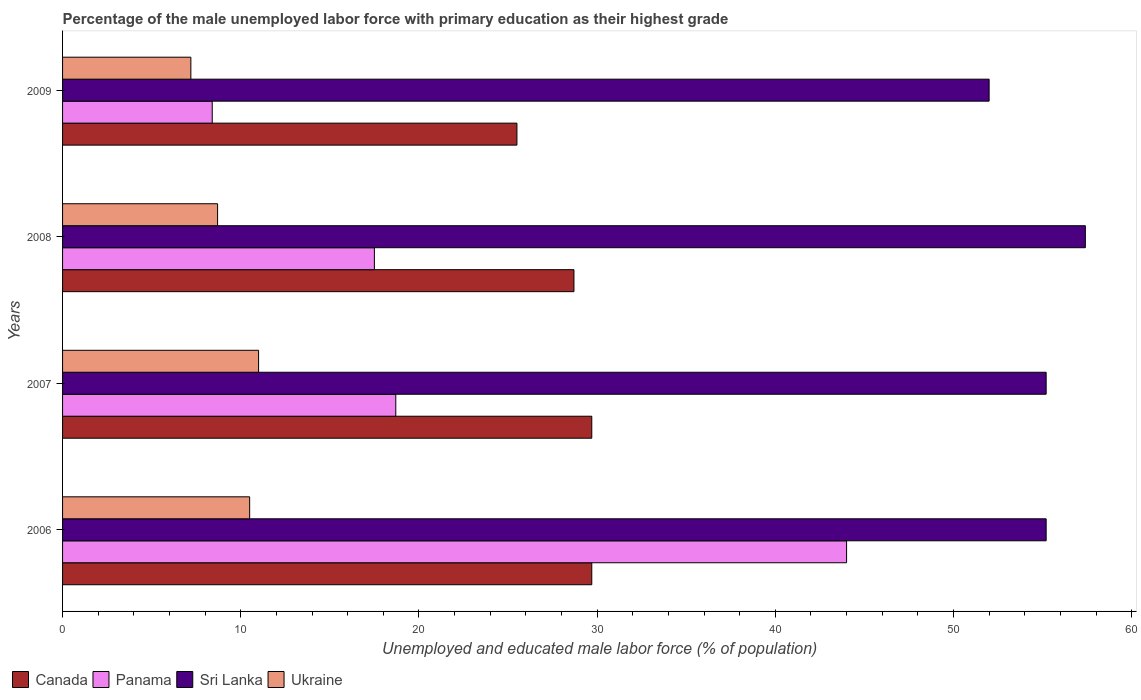How many different coloured bars are there?
Your answer should be compact. 4. How many groups of bars are there?
Make the answer very short. 4. Are the number of bars on each tick of the Y-axis equal?
Offer a terse response. Yes. How many bars are there on the 2nd tick from the top?
Give a very brief answer. 4. How many bars are there on the 1st tick from the bottom?
Offer a terse response. 4. In how many cases, is the number of bars for a given year not equal to the number of legend labels?
Keep it short and to the point. 0. What is the percentage of the unemployed male labor force with primary education in Canada in 2008?
Offer a very short reply. 28.7. Across all years, what is the maximum percentage of the unemployed male labor force with primary education in Canada?
Make the answer very short. 29.7. What is the total percentage of the unemployed male labor force with primary education in Sri Lanka in the graph?
Provide a succinct answer. 219.8. What is the difference between the percentage of the unemployed male labor force with primary education in Ukraine in 2006 and that in 2007?
Make the answer very short. -0.5. What is the difference between the percentage of the unemployed male labor force with primary education in Sri Lanka in 2006 and the percentage of the unemployed male labor force with primary education in Panama in 2007?
Provide a succinct answer. 36.5. What is the average percentage of the unemployed male labor force with primary education in Canada per year?
Your answer should be very brief. 28.4. In the year 2008, what is the difference between the percentage of the unemployed male labor force with primary education in Sri Lanka and percentage of the unemployed male labor force with primary education in Canada?
Make the answer very short. 28.7. What is the ratio of the percentage of the unemployed male labor force with primary education in Canada in 2006 to that in 2009?
Provide a short and direct response. 1.16. Is the percentage of the unemployed male labor force with primary education in Ukraine in 2006 less than that in 2008?
Make the answer very short. No. Is the difference between the percentage of the unemployed male labor force with primary education in Sri Lanka in 2006 and 2008 greater than the difference between the percentage of the unemployed male labor force with primary education in Canada in 2006 and 2008?
Make the answer very short. No. What is the difference between the highest and the second highest percentage of the unemployed male labor force with primary education in Panama?
Provide a succinct answer. 25.3. What is the difference between the highest and the lowest percentage of the unemployed male labor force with primary education in Canada?
Provide a succinct answer. 4.2. In how many years, is the percentage of the unemployed male labor force with primary education in Canada greater than the average percentage of the unemployed male labor force with primary education in Canada taken over all years?
Ensure brevity in your answer.  3. Is it the case that in every year, the sum of the percentage of the unemployed male labor force with primary education in Canada and percentage of the unemployed male labor force with primary education in Sri Lanka is greater than the sum of percentage of the unemployed male labor force with primary education in Panama and percentage of the unemployed male labor force with primary education in Ukraine?
Offer a terse response. Yes. What does the 1st bar from the top in 2008 represents?
Offer a very short reply. Ukraine. What does the 2nd bar from the bottom in 2007 represents?
Your answer should be very brief. Panama. How many bars are there?
Your answer should be compact. 16. How many years are there in the graph?
Your response must be concise. 4. How many legend labels are there?
Your answer should be very brief. 4. What is the title of the graph?
Your answer should be very brief. Percentage of the male unemployed labor force with primary education as their highest grade. Does "Finland" appear as one of the legend labels in the graph?
Ensure brevity in your answer.  No. What is the label or title of the X-axis?
Offer a very short reply. Unemployed and educated male labor force (% of population). What is the label or title of the Y-axis?
Make the answer very short. Years. What is the Unemployed and educated male labor force (% of population) of Canada in 2006?
Make the answer very short. 29.7. What is the Unemployed and educated male labor force (% of population) in Sri Lanka in 2006?
Keep it short and to the point. 55.2. What is the Unemployed and educated male labor force (% of population) in Ukraine in 2006?
Ensure brevity in your answer.  10.5. What is the Unemployed and educated male labor force (% of population) of Canada in 2007?
Ensure brevity in your answer.  29.7. What is the Unemployed and educated male labor force (% of population) in Panama in 2007?
Keep it short and to the point. 18.7. What is the Unemployed and educated male labor force (% of population) in Sri Lanka in 2007?
Keep it short and to the point. 55.2. What is the Unemployed and educated male labor force (% of population) of Ukraine in 2007?
Keep it short and to the point. 11. What is the Unemployed and educated male labor force (% of population) of Canada in 2008?
Provide a short and direct response. 28.7. What is the Unemployed and educated male labor force (% of population) in Panama in 2008?
Your answer should be very brief. 17.5. What is the Unemployed and educated male labor force (% of population) in Sri Lanka in 2008?
Provide a short and direct response. 57.4. What is the Unemployed and educated male labor force (% of population) of Ukraine in 2008?
Give a very brief answer. 8.7. What is the Unemployed and educated male labor force (% of population) in Panama in 2009?
Your response must be concise. 8.4. What is the Unemployed and educated male labor force (% of population) of Ukraine in 2009?
Provide a short and direct response. 7.2. Across all years, what is the maximum Unemployed and educated male labor force (% of population) of Canada?
Your answer should be compact. 29.7. Across all years, what is the maximum Unemployed and educated male labor force (% of population) of Panama?
Your answer should be compact. 44. Across all years, what is the maximum Unemployed and educated male labor force (% of population) in Sri Lanka?
Give a very brief answer. 57.4. Across all years, what is the maximum Unemployed and educated male labor force (% of population) in Ukraine?
Ensure brevity in your answer.  11. Across all years, what is the minimum Unemployed and educated male labor force (% of population) in Canada?
Give a very brief answer. 25.5. Across all years, what is the minimum Unemployed and educated male labor force (% of population) in Panama?
Offer a terse response. 8.4. Across all years, what is the minimum Unemployed and educated male labor force (% of population) in Sri Lanka?
Ensure brevity in your answer.  52. Across all years, what is the minimum Unemployed and educated male labor force (% of population) of Ukraine?
Your response must be concise. 7.2. What is the total Unemployed and educated male labor force (% of population) of Canada in the graph?
Keep it short and to the point. 113.6. What is the total Unemployed and educated male labor force (% of population) in Panama in the graph?
Give a very brief answer. 88.6. What is the total Unemployed and educated male labor force (% of population) in Sri Lanka in the graph?
Provide a short and direct response. 219.8. What is the total Unemployed and educated male labor force (% of population) in Ukraine in the graph?
Ensure brevity in your answer.  37.4. What is the difference between the Unemployed and educated male labor force (% of population) of Panama in 2006 and that in 2007?
Your response must be concise. 25.3. What is the difference between the Unemployed and educated male labor force (% of population) of Sri Lanka in 2006 and that in 2007?
Give a very brief answer. 0. What is the difference between the Unemployed and educated male labor force (% of population) of Ukraine in 2006 and that in 2007?
Your response must be concise. -0.5. What is the difference between the Unemployed and educated male labor force (% of population) of Canada in 2006 and that in 2008?
Ensure brevity in your answer.  1. What is the difference between the Unemployed and educated male labor force (% of population) of Sri Lanka in 2006 and that in 2008?
Give a very brief answer. -2.2. What is the difference between the Unemployed and educated male labor force (% of population) in Panama in 2006 and that in 2009?
Your answer should be very brief. 35.6. What is the difference between the Unemployed and educated male labor force (% of population) of Ukraine in 2006 and that in 2009?
Offer a very short reply. 3.3. What is the difference between the Unemployed and educated male labor force (% of population) of Canada in 2007 and that in 2008?
Offer a very short reply. 1. What is the difference between the Unemployed and educated male labor force (% of population) in Panama in 2007 and that in 2008?
Offer a very short reply. 1.2. What is the difference between the Unemployed and educated male labor force (% of population) in Sri Lanka in 2007 and that in 2008?
Keep it short and to the point. -2.2. What is the difference between the Unemployed and educated male labor force (% of population) of Canada in 2007 and that in 2009?
Your response must be concise. 4.2. What is the difference between the Unemployed and educated male labor force (% of population) of Ukraine in 2007 and that in 2009?
Provide a succinct answer. 3.8. What is the difference between the Unemployed and educated male labor force (% of population) in Panama in 2008 and that in 2009?
Give a very brief answer. 9.1. What is the difference between the Unemployed and educated male labor force (% of population) of Sri Lanka in 2008 and that in 2009?
Your answer should be very brief. 5.4. What is the difference between the Unemployed and educated male labor force (% of population) of Canada in 2006 and the Unemployed and educated male labor force (% of population) of Panama in 2007?
Ensure brevity in your answer.  11. What is the difference between the Unemployed and educated male labor force (% of population) of Canada in 2006 and the Unemployed and educated male labor force (% of population) of Sri Lanka in 2007?
Provide a short and direct response. -25.5. What is the difference between the Unemployed and educated male labor force (% of population) of Panama in 2006 and the Unemployed and educated male labor force (% of population) of Ukraine in 2007?
Your response must be concise. 33. What is the difference between the Unemployed and educated male labor force (% of population) in Sri Lanka in 2006 and the Unemployed and educated male labor force (% of population) in Ukraine in 2007?
Your answer should be compact. 44.2. What is the difference between the Unemployed and educated male labor force (% of population) in Canada in 2006 and the Unemployed and educated male labor force (% of population) in Panama in 2008?
Provide a short and direct response. 12.2. What is the difference between the Unemployed and educated male labor force (% of population) of Canada in 2006 and the Unemployed and educated male labor force (% of population) of Sri Lanka in 2008?
Offer a terse response. -27.7. What is the difference between the Unemployed and educated male labor force (% of population) of Canada in 2006 and the Unemployed and educated male labor force (% of population) of Ukraine in 2008?
Your response must be concise. 21. What is the difference between the Unemployed and educated male labor force (% of population) in Panama in 2006 and the Unemployed and educated male labor force (% of population) in Ukraine in 2008?
Ensure brevity in your answer.  35.3. What is the difference between the Unemployed and educated male labor force (% of population) in Sri Lanka in 2006 and the Unemployed and educated male labor force (% of population) in Ukraine in 2008?
Offer a terse response. 46.5. What is the difference between the Unemployed and educated male labor force (% of population) of Canada in 2006 and the Unemployed and educated male labor force (% of population) of Panama in 2009?
Provide a short and direct response. 21.3. What is the difference between the Unemployed and educated male labor force (% of population) of Canada in 2006 and the Unemployed and educated male labor force (% of population) of Sri Lanka in 2009?
Make the answer very short. -22.3. What is the difference between the Unemployed and educated male labor force (% of population) in Canada in 2006 and the Unemployed and educated male labor force (% of population) in Ukraine in 2009?
Provide a short and direct response. 22.5. What is the difference between the Unemployed and educated male labor force (% of population) of Panama in 2006 and the Unemployed and educated male labor force (% of population) of Ukraine in 2009?
Your answer should be very brief. 36.8. What is the difference between the Unemployed and educated male labor force (% of population) in Canada in 2007 and the Unemployed and educated male labor force (% of population) in Sri Lanka in 2008?
Give a very brief answer. -27.7. What is the difference between the Unemployed and educated male labor force (% of population) of Canada in 2007 and the Unemployed and educated male labor force (% of population) of Ukraine in 2008?
Make the answer very short. 21. What is the difference between the Unemployed and educated male labor force (% of population) of Panama in 2007 and the Unemployed and educated male labor force (% of population) of Sri Lanka in 2008?
Offer a terse response. -38.7. What is the difference between the Unemployed and educated male labor force (% of population) of Sri Lanka in 2007 and the Unemployed and educated male labor force (% of population) of Ukraine in 2008?
Your answer should be compact. 46.5. What is the difference between the Unemployed and educated male labor force (% of population) of Canada in 2007 and the Unemployed and educated male labor force (% of population) of Panama in 2009?
Give a very brief answer. 21.3. What is the difference between the Unemployed and educated male labor force (% of population) in Canada in 2007 and the Unemployed and educated male labor force (% of population) in Sri Lanka in 2009?
Make the answer very short. -22.3. What is the difference between the Unemployed and educated male labor force (% of population) in Panama in 2007 and the Unemployed and educated male labor force (% of population) in Sri Lanka in 2009?
Ensure brevity in your answer.  -33.3. What is the difference between the Unemployed and educated male labor force (% of population) of Panama in 2007 and the Unemployed and educated male labor force (% of population) of Ukraine in 2009?
Your answer should be very brief. 11.5. What is the difference between the Unemployed and educated male labor force (% of population) of Sri Lanka in 2007 and the Unemployed and educated male labor force (% of population) of Ukraine in 2009?
Your response must be concise. 48. What is the difference between the Unemployed and educated male labor force (% of population) in Canada in 2008 and the Unemployed and educated male labor force (% of population) in Panama in 2009?
Your response must be concise. 20.3. What is the difference between the Unemployed and educated male labor force (% of population) of Canada in 2008 and the Unemployed and educated male labor force (% of population) of Sri Lanka in 2009?
Your response must be concise. -23.3. What is the difference between the Unemployed and educated male labor force (% of population) of Canada in 2008 and the Unemployed and educated male labor force (% of population) of Ukraine in 2009?
Offer a terse response. 21.5. What is the difference between the Unemployed and educated male labor force (% of population) in Panama in 2008 and the Unemployed and educated male labor force (% of population) in Sri Lanka in 2009?
Offer a very short reply. -34.5. What is the difference between the Unemployed and educated male labor force (% of population) of Sri Lanka in 2008 and the Unemployed and educated male labor force (% of population) of Ukraine in 2009?
Provide a succinct answer. 50.2. What is the average Unemployed and educated male labor force (% of population) of Canada per year?
Ensure brevity in your answer.  28.4. What is the average Unemployed and educated male labor force (% of population) of Panama per year?
Keep it short and to the point. 22.15. What is the average Unemployed and educated male labor force (% of population) in Sri Lanka per year?
Offer a very short reply. 54.95. What is the average Unemployed and educated male labor force (% of population) in Ukraine per year?
Offer a terse response. 9.35. In the year 2006, what is the difference between the Unemployed and educated male labor force (% of population) in Canada and Unemployed and educated male labor force (% of population) in Panama?
Your answer should be very brief. -14.3. In the year 2006, what is the difference between the Unemployed and educated male labor force (% of population) in Canada and Unemployed and educated male labor force (% of population) in Sri Lanka?
Make the answer very short. -25.5. In the year 2006, what is the difference between the Unemployed and educated male labor force (% of population) in Canada and Unemployed and educated male labor force (% of population) in Ukraine?
Your answer should be compact. 19.2. In the year 2006, what is the difference between the Unemployed and educated male labor force (% of population) in Panama and Unemployed and educated male labor force (% of population) in Sri Lanka?
Your answer should be compact. -11.2. In the year 2006, what is the difference between the Unemployed and educated male labor force (% of population) in Panama and Unemployed and educated male labor force (% of population) in Ukraine?
Offer a very short reply. 33.5. In the year 2006, what is the difference between the Unemployed and educated male labor force (% of population) of Sri Lanka and Unemployed and educated male labor force (% of population) of Ukraine?
Keep it short and to the point. 44.7. In the year 2007, what is the difference between the Unemployed and educated male labor force (% of population) of Canada and Unemployed and educated male labor force (% of population) of Panama?
Your answer should be very brief. 11. In the year 2007, what is the difference between the Unemployed and educated male labor force (% of population) in Canada and Unemployed and educated male labor force (% of population) in Sri Lanka?
Give a very brief answer. -25.5. In the year 2007, what is the difference between the Unemployed and educated male labor force (% of population) of Panama and Unemployed and educated male labor force (% of population) of Sri Lanka?
Ensure brevity in your answer.  -36.5. In the year 2007, what is the difference between the Unemployed and educated male labor force (% of population) of Panama and Unemployed and educated male labor force (% of population) of Ukraine?
Keep it short and to the point. 7.7. In the year 2007, what is the difference between the Unemployed and educated male labor force (% of population) in Sri Lanka and Unemployed and educated male labor force (% of population) in Ukraine?
Your answer should be compact. 44.2. In the year 2008, what is the difference between the Unemployed and educated male labor force (% of population) of Canada and Unemployed and educated male labor force (% of population) of Panama?
Offer a very short reply. 11.2. In the year 2008, what is the difference between the Unemployed and educated male labor force (% of population) of Canada and Unemployed and educated male labor force (% of population) of Sri Lanka?
Ensure brevity in your answer.  -28.7. In the year 2008, what is the difference between the Unemployed and educated male labor force (% of population) in Canada and Unemployed and educated male labor force (% of population) in Ukraine?
Your answer should be compact. 20. In the year 2008, what is the difference between the Unemployed and educated male labor force (% of population) in Panama and Unemployed and educated male labor force (% of population) in Sri Lanka?
Provide a short and direct response. -39.9. In the year 2008, what is the difference between the Unemployed and educated male labor force (% of population) in Panama and Unemployed and educated male labor force (% of population) in Ukraine?
Offer a very short reply. 8.8. In the year 2008, what is the difference between the Unemployed and educated male labor force (% of population) of Sri Lanka and Unemployed and educated male labor force (% of population) of Ukraine?
Your answer should be very brief. 48.7. In the year 2009, what is the difference between the Unemployed and educated male labor force (% of population) of Canada and Unemployed and educated male labor force (% of population) of Sri Lanka?
Your answer should be compact. -26.5. In the year 2009, what is the difference between the Unemployed and educated male labor force (% of population) of Panama and Unemployed and educated male labor force (% of population) of Sri Lanka?
Your answer should be compact. -43.6. In the year 2009, what is the difference between the Unemployed and educated male labor force (% of population) of Sri Lanka and Unemployed and educated male labor force (% of population) of Ukraine?
Offer a terse response. 44.8. What is the ratio of the Unemployed and educated male labor force (% of population) in Panama in 2006 to that in 2007?
Make the answer very short. 2.35. What is the ratio of the Unemployed and educated male labor force (% of population) of Sri Lanka in 2006 to that in 2007?
Make the answer very short. 1. What is the ratio of the Unemployed and educated male labor force (% of population) of Ukraine in 2006 to that in 2007?
Provide a short and direct response. 0.95. What is the ratio of the Unemployed and educated male labor force (% of population) in Canada in 2006 to that in 2008?
Your answer should be very brief. 1.03. What is the ratio of the Unemployed and educated male labor force (% of population) in Panama in 2006 to that in 2008?
Your answer should be compact. 2.51. What is the ratio of the Unemployed and educated male labor force (% of population) in Sri Lanka in 2006 to that in 2008?
Offer a very short reply. 0.96. What is the ratio of the Unemployed and educated male labor force (% of population) of Ukraine in 2006 to that in 2008?
Provide a short and direct response. 1.21. What is the ratio of the Unemployed and educated male labor force (% of population) in Canada in 2006 to that in 2009?
Keep it short and to the point. 1.16. What is the ratio of the Unemployed and educated male labor force (% of population) of Panama in 2006 to that in 2009?
Your response must be concise. 5.24. What is the ratio of the Unemployed and educated male labor force (% of population) in Sri Lanka in 2006 to that in 2009?
Offer a terse response. 1.06. What is the ratio of the Unemployed and educated male labor force (% of population) of Ukraine in 2006 to that in 2009?
Your answer should be very brief. 1.46. What is the ratio of the Unemployed and educated male labor force (% of population) in Canada in 2007 to that in 2008?
Provide a short and direct response. 1.03. What is the ratio of the Unemployed and educated male labor force (% of population) in Panama in 2007 to that in 2008?
Keep it short and to the point. 1.07. What is the ratio of the Unemployed and educated male labor force (% of population) of Sri Lanka in 2007 to that in 2008?
Give a very brief answer. 0.96. What is the ratio of the Unemployed and educated male labor force (% of population) of Ukraine in 2007 to that in 2008?
Provide a succinct answer. 1.26. What is the ratio of the Unemployed and educated male labor force (% of population) of Canada in 2007 to that in 2009?
Offer a terse response. 1.16. What is the ratio of the Unemployed and educated male labor force (% of population) in Panama in 2007 to that in 2009?
Your answer should be very brief. 2.23. What is the ratio of the Unemployed and educated male labor force (% of population) of Sri Lanka in 2007 to that in 2009?
Provide a succinct answer. 1.06. What is the ratio of the Unemployed and educated male labor force (% of population) of Ukraine in 2007 to that in 2009?
Your answer should be compact. 1.53. What is the ratio of the Unemployed and educated male labor force (% of population) of Canada in 2008 to that in 2009?
Make the answer very short. 1.13. What is the ratio of the Unemployed and educated male labor force (% of population) in Panama in 2008 to that in 2009?
Your answer should be very brief. 2.08. What is the ratio of the Unemployed and educated male labor force (% of population) of Sri Lanka in 2008 to that in 2009?
Ensure brevity in your answer.  1.1. What is the ratio of the Unemployed and educated male labor force (% of population) in Ukraine in 2008 to that in 2009?
Provide a succinct answer. 1.21. What is the difference between the highest and the second highest Unemployed and educated male labor force (% of population) of Canada?
Keep it short and to the point. 0. What is the difference between the highest and the second highest Unemployed and educated male labor force (% of population) in Panama?
Give a very brief answer. 25.3. What is the difference between the highest and the second highest Unemployed and educated male labor force (% of population) in Sri Lanka?
Provide a succinct answer. 2.2. What is the difference between the highest and the lowest Unemployed and educated male labor force (% of population) of Canada?
Your answer should be compact. 4.2. What is the difference between the highest and the lowest Unemployed and educated male labor force (% of population) of Panama?
Keep it short and to the point. 35.6. What is the difference between the highest and the lowest Unemployed and educated male labor force (% of population) of Sri Lanka?
Ensure brevity in your answer.  5.4. What is the difference between the highest and the lowest Unemployed and educated male labor force (% of population) of Ukraine?
Give a very brief answer. 3.8. 